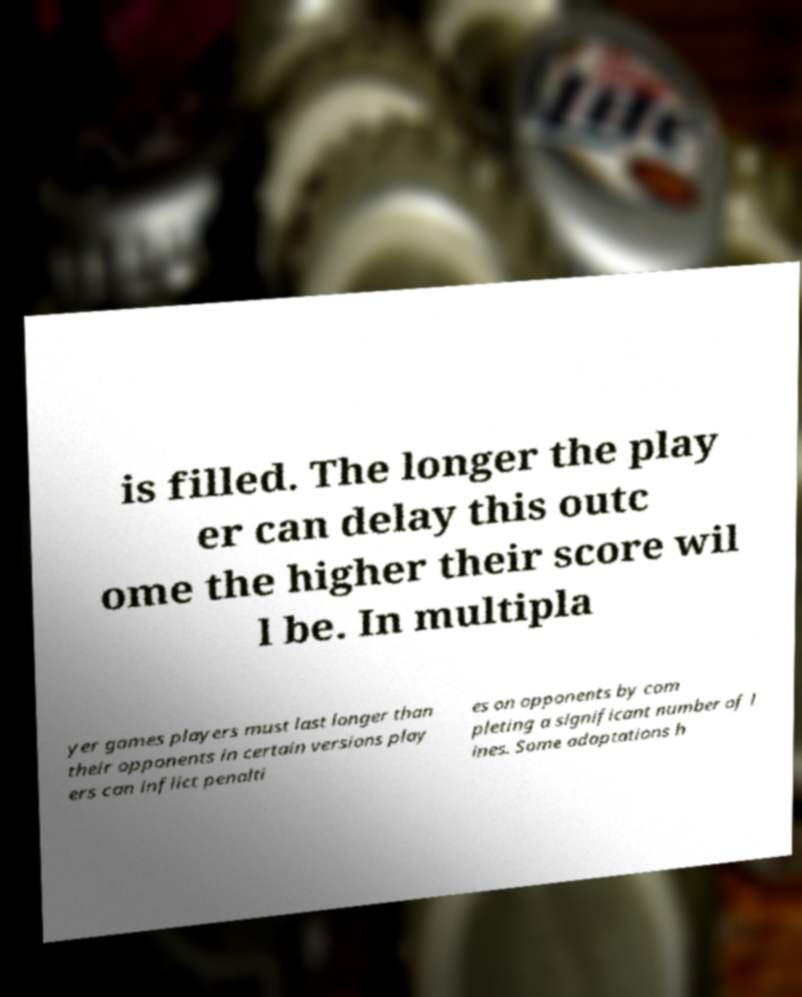Please read and relay the text visible in this image. What does it say? is filled. The longer the play er can delay this outc ome the higher their score wil l be. In multipla yer games players must last longer than their opponents in certain versions play ers can inflict penalti es on opponents by com pleting a significant number of l ines. Some adaptations h 